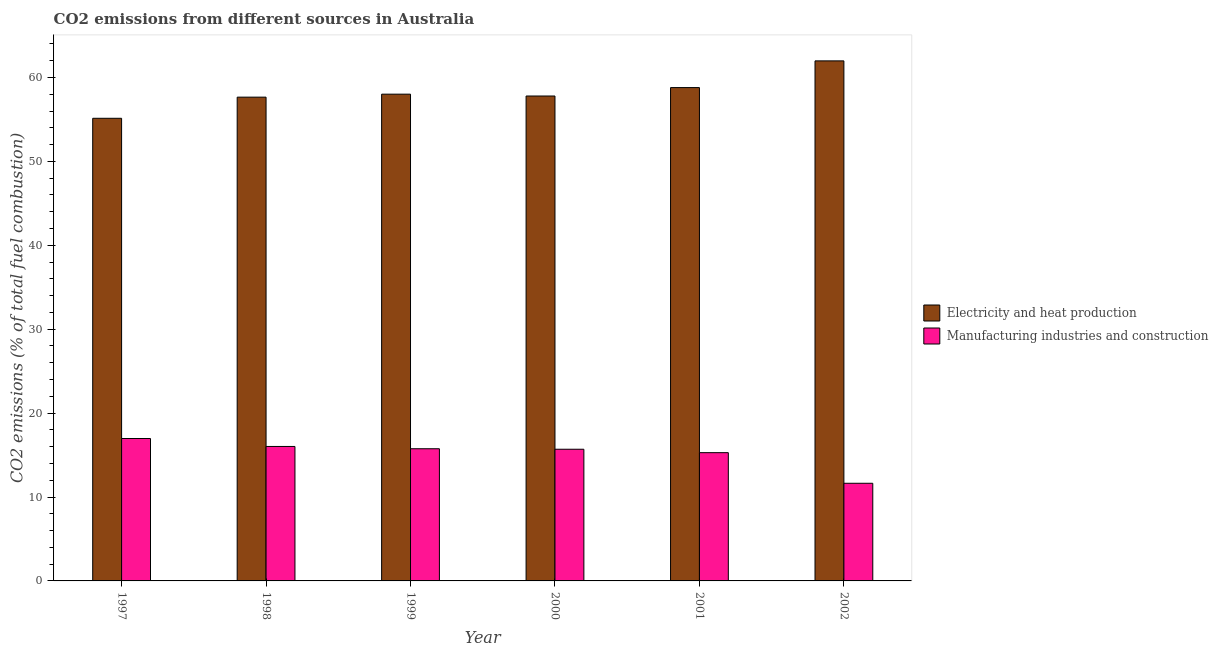How many different coloured bars are there?
Provide a succinct answer. 2. How many groups of bars are there?
Provide a short and direct response. 6. Are the number of bars on each tick of the X-axis equal?
Keep it short and to the point. Yes. How many bars are there on the 2nd tick from the left?
Your answer should be very brief. 2. How many bars are there on the 3rd tick from the right?
Ensure brevity in your answer.  2. What is the label of the 5th group of bars from the left?
Make the answer very short. 2001. In how many cases, is the number of bars for a given year not equal to the number of legend labels?
Offer a very short reply. 0. What is the co2 emissions due to electricity and heat production in 1999?
Your answer should be very brief. 58.01. Across all years, what is the maximum co2 emissions due to manufacturing industries?
Keep it short and to the point. 16.97. Across all years, what is the minimum co2 emissions due to electricity and heat production?
Make the answer very short. 55.14. In which year was the co2 emissions due to electricity and heat production maximum?
Provide a succinct answer. 2002. What is the total co2 emissions due to electricity and heat production in the graph?
Provide a short and direct response. 349.38. What is the difference between the co2 emissions due to manufacturing industries in 1998 and that in 2002?
Your response must be concise. 4.39. What is the difference between the co2 emissions due to electricity and heat production in 2000 and the co2 emissions due to manufacturing industries in 2002?
Offer a terse response. -4.19. What is the average co2 emissions due to electricity and heat production per year?
Provide a short and direct response. 58.23. What is the ratio of the co2 emissions due to manufacturing industries in 1998 to that in 2002?
Make the answer very short. 1.38. Is the difference between the co2 emissions due to electricity and heat production in 1998 and 2002 greater than the difference between the co2 emissions due to manufacturing industries in 1998 and 2002?
Your response must be concise. No. What is the difference between the highest and the second highest co2 emissions due to electricity and heat production?
Ensure brevity in your answer.  3.18. What is the difference between the highest and the lowest co2 emissions due to manufacturing industries?
Provide a succinct answer. 5.34. In how many years, is the co2 emissions due to manufacturing industries greater than the average co2 emissions due to manufacturing industries taken over all years?
Provide a short and direct response. 5. Is the sum of the co2 emissions due to electricity and heat production in 1998 and 2001 greater than the maximum co2 emissions due to manufacturing industries across all years?
Provide a short and direct response. Yes. What does the 2nd bar from the left in 2002 represents?
Your answer should be compact. Manufacturing industries and construction. What does the 2nd bar from the right in 1997 represents?
Provide a short and direct response. Electricity and heat production. Are all the bars in the graph horizontal?
Your answer should be compact. No. Where does the legend appear in the graph?
Offer a terse response. Center right. How many legend labels are there?
Ensure brevity in your answer.  2. How are the legend labels stacked?
Keep it short and to the point. Vertical. What is the title of the graph?
Your answer should be very brief. CO2 emissions from different sources in Australia. What is the label or title of the Y-axis?
Offer a very short reply. CO2 emissions (% of total fuel combustion). What is the CO2 emissions (% of total fuel combustion) in Electricity and heat production in 1997?
Offer a very short reply. 55.14. What is the CO2 emissions (% of total fuel combustion) of Manufacturing industries and construction in 1997?
Provide a short and direct response. 16.97. What is the CO2 emissions (% of total fuel combustion) of Electricity and heat production in 1998?
Provide a short and direct response. 57.66. What is the CO2 emissions (% of total fuel combustion) in Manufacturing industries and construction in 1998?
Offer a very short reply. 16.03. What is the CO2 emissions (% of total fuel combustion) in Electricity and heat production in 1999?
Provide a short and direct response. 58.01. What is the CO2 emissions (% of total fuel combustion) in Manufacturing industries and construction in 1999?
Provide a short and direct response. 15.75. What is the CO2 emissions (% of total fuel combustion) in Electricity and heat production in 2000?
Offer a very short reply. 57.79. What is the CO2 emissions (% of total fuel combustion) of Manufacturing industries and construction in 2000?
Ensure brevity in your answer.  15.69. What is the CO2 emissions (% of total fuel combustion) in Electricity and heat production in 2001?
Provide a succinct answer. 58.8. What is the CO2 emissions (% of total fuel combustion) in Manufacturing industries and construction in 2001?
Offer a terse response. 15.29. What is the CO2 emissions (% of total fuel combustion) of Electricity and heat production in 2002?
Provide a short and direct response. 61.98. What is the CO2 emissions (% of total fuel combustion) of Manufacturing industries and construction in 2002?
Offer a very short reply. 11.64. Across all years, what is the maximum CO2 emissions (% of total fuel combustion) of Electricity and heat production?
Your answer should be compact. 61.98. Across all years, what is the maximum CO2 emissions (% of total fuel combustion) in Manufacturing industries and construction?
Ensure brevity in your answer.  16.97. Across all years, what is the minimum CO2 emissions (% of total fuel combustion) in Electricity and heat production?
Keep it short and to the point. 55.14. Across all years, what is the minimum CO2 emissions (% of total fuel combustion) of Manufacturing industries and construction?
Your answer should be compact. 11.64. What is the total CO2 emissions (% of total fuel combustion) in Electricity and heat production in the graph?
Provide a succinct answer. 349.38. What is the total CO2 emissions (% of total fuel combustion) in Manufacturing industries and construction in the graph?
Keep it short and to the point. 91.37. What is the difference between the CO2 emissions (% of total fuel combustion) of Electricity and heat production in 1997 and that in 1998?
Ensure brevity in your answer.  -2.52. What is the difference between the CO2 emissions (% of total fuel combustion) of Manufacturing industries and construction in 1997 and that in 1998?
Keep it short and to the point. 0.95. What is the difference between the CO2 emissions (% of total fuel combustion) in Electricity and heat production in 1997 and that in 1999?
Make the answer very short. -2.88. What is the difference between the CO2 emissions (% of total fuel combustion) in Manufacturing industries and construction in 1997 and that in 1999?
Offer a very short reply. 1.22. What is the difference between the CO2 emissions (% of total fuel combustion) in Electricity and heat production in 1997 and that in 2000?
Your answer should be very brief. -2.66. What is the difference between the CO2 emissions (% of total fuel combustion) of Manufacturing industries and construction in 1997 and that in 2000?
Keep it short and to the point. 1.28. What is the difference between the CO2 emissions (% of total fuel combustion) in Electricity and heat production in 1997 and that in 2001?
Ensure brevity in your answer.  -3.66. What is the difference between the CO2 emissions (% of total fuel combustion) of Manufacturing industries and construction in 1997 and that in 2001?
Make the answer very short. 1.69. What is the difference between the CO2 emissions (% of total fuel combustion) in Electricity and heat production in 1997 and that in 2002?
Your answer should be compact. -6.84. What is the difference between the CO2 emissions (% of total fuel combustion) of Manufacturing industries and construction in 1997 and that in 2002?
Ensure brevity in your answer.  5.34. What is the difference between the CO2 emissions (% of total fuel combustion) of Electricity and heat production in 1998 and that in 1999?
Offer a terse response. -0.36. What is the difference between the CO2 emissions (% of total fuel combustion) in Manufacturing industries and construction in 1998 and that in 1999?
Provide a short and direct response. 0.27. What is the difference between the CO2 emissions (% of total fuel combustion) of Electricity and heat production in 1998 and that in 2000?
Offer a terse response. -0.14. What is the difference between the CO2 emissions (% of total fuel combustion) in Manufacturing industries and construction in 1998 and that in 2000?
Keep it short and to the point. 0.33. What is the difference between the CO2 emissions (% of total fuel combustion) in Electricity and heat production in 1998 and that in 2001?
Ensure brevity in your answer.  -1.14. What is the difference between the CO2 emissions (% of total fuel combustion) in Manufacturing industries and construction in 1998 and that in 2001?
Offer a terse response. 0.74. What is the difference between the CO2 emissions (% of total fuel combustion) in Electricity and heat production in 1998 and that in 2002?
Keep it short and to the point. -4.32. What is the difference between the CO2 emissions (% of total fuel combustion) in Manufacturing industries and construction in 1998 and that in 2002?
Keep it short and to the point. 4.39. What is the difference between the CO2 emissions (% of total fuel combustion) in Electricity and heat production in 1999 and that in 2000?
Provide a succinct answer. 0.22. What is the difference between the CO2 emissions (% of total fuel combustion) in Manufacturing industries and construction in 1999 and that in 2000?
Your answer should be compact. 0.06. What is the difference between the CO2 emissions (% of total fuel combustion) in Electricity and heat production in 1999 and that in 2001?
Give a very brief answer. -0.78. What is the difference between the CO2 emissions (% of total fuel combustion) of Manufacturing industries and construction in 1999 and that in 2001?
Your answer should be compact. 0.47. What is the difference between the CO2 emissions (% of total fuel combustion) in Electricity and heat production in 1999 and that in 2002?
Your answer should be very brief. -3.97. What is the difference between the CO2 emissions (% of total fuel combustion) of Manufacturing industries and construction in 1999 and that in 2002?
Provide a succinct answer. 4.12. What is the difference between the CO2 emissions (% of total fuel combustion) in Electricity and heat production in 2000 and that in 2001?
Offer a terse response. -1.01. What is the difference between the CO2 emissions (% of total fuel combustion) of Manufacturing industries and construction in 2000 and that in 2001?
Your answer should be compact. 0.41. What is the difference between the CO2 emissions (% of total fuel combustion) in Electricity and heat production in 2000 and that in 2002?
Offer a terse response. -4.19. What is the difference between the CO2 emissions (% of total fuel combustion) in Manufacturing industries and construction in 2000 and that in 2002?
Give a very brief answer. 4.06. What is the difference between the CO2 emissions (% of total fuel combustion) of Electricity and heat production in 2001 and that in 2002?
Ensure brevity in your answer.  -3.18. What is the difference between the CO2 emissions (% of total fuel combustion) of Manufacturing industries and construction in 2001 and that in 2002?
Offer a very short reply. 3.65. What is the difference between the CO2 emissions (% of total fuel combustion) of Electricity and heat production in 1997 and the CO2 emissions (% of total fuel combustion) of Manufacturing industries and construction in 1998?
Your answer should be compact. 39.11. What is the difference between the CO2 emissions (% of total fuel combustion) of Electricity and heat production in 1997 and the CO2 emissions (% of total fuel combustion) of Manufacturing industries and construction in 1999?
Keep it short and to the point. 39.38. What is the difference between the CO2 emissions (% of total fuel combustion) in Electricity and heat production in 1997 and the CO2 emissions (% of total fuel combustion) in Manufacturing industries and construction in 2000?
Ensure brevity in your answer.  39.44. What is the difference between the CO2 emissions (% of total fuel combustion) of Electricity and heat production in 1997 and the CO2 emissions (% of total fuel combustion) of Manufacturing industries and construction in 2001?
Offer a very short reply. 39.85. What is the difference between the CO2 emissions (% of total fuel combustion) in Electricity and heat production in 1997 and the CO2 emissions (% of total fuel combustion) in Manufacturing industries and construction in 2002?
Your answer should be compact. 43.5. What is the difference between the CO2 emissions (% of total fuel combustion) in Electricity and heat production in 1998 and the CO2 emissions (% of total fuel combustion) in Manufacturing industries and construction in 1999?
Make the answer very short. 41.91. What is the difference between the CO2 emissions (% of total fuel combustion) in Electricity and heat production in 1998 and the CO2 emissions (% of total fuel combustion) in Manufacturing industries and construction in 2000?
Ensure brevity in your answer.  41.96. What is the difference between the CO2 emissions (% of total fuel combustion) in Electricity and heat production in 1998 and the CO2 emissions (% of total fuel combustion) in Manufacturing industries and construction in 2001?
Ensure brevity in your answer.  42.37. What is the difference between the CO2 emissions (% of total fuel combustion) in Electricity and heat production in 1998 and the CO2 emissions (% of total fuel combustion) in Manufacturing industries and construction in 2002?
Give a very brief answer. 46.02. What is the difference between the CO2 emissions (% of total fuel combustion) in Electricity and heat production in 1999 and the CO2 emissions (% of total fuel combustion) in Manufacturing industries and construction in 2000?
Make the answer very short. 42.32. What is the difference between the CO2 emissions (% of total fuel combustion) in Electricity and heat production in 1999 and the CO2 emissions (% of total fuel combustion) in Manufacturing industries and construction in 2001?
Offer a terse response. 42.73. What is the difference between the CO2 emissions (% of total fuel combustion) in Electricity and heat production in 1999 and the CO2 emissions (% of total fuel combustion) in Manufacturing industries and construction in 2002?
Make the answer very short. 46.38. What is the difference between the CO2 emissions (% of total fuel combustion) in Electricity and heat production in 2000 and the CO2 emissions (% of total fuel combustion) in Manufacturing industries and construction in 2001?
Offer a terse response. 42.51. What is the difference between the CO2 emissions (% of total fuel combustion) in Electricity and heat production in 2000 and the CO2 emissions (% of total fuel combustion) in Manufacturing industries and construction in 2002?
Your response must be concise. 46.16. What is the difference between the CO2 emissions (% of total fuel combustion) in Electricity and heat production in 2001 and the CO2 emissions (% of total fuel combustion) in Manufacturing industries and construction in 2002?
Your response must be concise. 47.16. What is the average CO2 emissions (% of total fuel combustion) of Electricity and heat production per year?
Give a very brief answer. 58.23. What is the average CO2 emissions (% of total fuel combustion) in Manufacturing industries and construction per year?
Your answer should be compact. 15.23. In the year 1997, what is the difference between the CO2 emissions (% of total fuel combustion) of Electricity and heat production and CO2 emissions (% of total fuel combustion) of Manufacturing industries and construction?
Ensure brevity in your answer.  38.16. In the year 1998, what is the difference between the CO2 emissions (% of total fuel combustion) in Electricity and heat production and CO2 emissions (% of total fuel combustion) in Manufacturing industries and construction?
Provide a short and direct response. 41.63. In the year 1999, what is the difference between the CO2 emissions (% of total fuel combustion) of Electricity and heat production and CO2 emissions (% of total fuel combustion) of Manufacturing industries and construction?
Your response must be concise. 42.26. In the year 2000, what is the difference between the CO2 emissions (% of total fuel combustion) of Electricity and heat production and CO2 emissions (% of total fuel combustion) of Manufacturing industries and construction?
Offer a terse response. 42.1. In the year 2001, what is the difference between the CO2 emissions (% of total fuel combustion) in Electricity and heat production and CO2 emissions (% of total fuel combustion) in Manufacturing industries and construction?
Keep it short and to the point. 43.51. In the year 2002, what is the difference between the CO2 emissions (% of total fuel combustion) in Electricity and heat production and CO2 emissions (% of total fuel combustion) in Manufacturing industries and construction?
Offer a very short reply. 50.34. What is the ratio of the CO2 emissions (% of total fuel combustion) in Electricity and heat production in 1997 to that in 1998?
Ensure brevity in your answer.  0.96. What is the ratio of the CO2 emissions (% of total fuel combustion) in Manufacturing industries and construction in 1997 to that in 1998?
Your answer should be compact. 1.06. What is the ratio of the CO2 emissions (% of total fuel combustion) in Electricity and heat production in 1997 to that in 1999?
Provide a short and direct response. 0.95. What is the ratio of the CO2 emissions (% of total fuel combustion) of Manufacturing industries and construction in 1997 to that in 1999?
Your answer should be very brief. 1.08. What is the ratio of the CO2 emissions (% of total fuel combustion) of Electricity and heat production in 1997 to that in 2000?
Your answer should be very brief. 0.95. What is the ratio of the CO2 emissions (% of total fuel combustion) of Manufacturing industries and construction in 1997 to that in 2000?
Your answer should be very brief. 1.08. What is the ratio of the CO2 emissions (% of total fuel combustion) of Electricity and heat production in 1997 to that in 2001?
Your response must be concise. 0.94. What is the ratio of the CO2 emissions (% of total fuel combustion) in Manufacturing industries and construction in 1997 to that in 2001?
Make the answer very short. 1.11. What is the ratio of the CO2 emissions (% of total fuel combustion) in Electricity and heat production in 1997 to that in 2002?
Your response must be concise. 0.89. What is the ratio of the CO2 emissions (% of total fuel combustion) in Manufacturing industries and construction in 1997 to that in 2002?
Provide a succinct answer. 1.46. What is the ratio of the CO2 emissions (% of total fuel combustion) of Electricity and heat production in 1998 to that in 1999?
Make the answer very short. 0.99. What is the ratio of the CO2 emissions (% of total fuel combustion) of Manufacturing industries and construction in 1998 to that in 1999?
Offer a terse response. 1.02. What is the ratio of the CO2 emissions (% of total fuel combustion) in Manufacturing industries and construction in 1998 to that in 2000?
Keep it short and to the point. 1.02. What is the ratio of the CO2 emissions (% of total fuel combustion) of Electricity and heat production in 1998 to that in 2001?
Provide a succinct answer. 0.98. What is the ratio of the CO2 emissions (% of total fuel combustion) of Manufacturing industries and construction in 1998 to that in 2001?
Make the answer very short. 1.05. What is the ratio of the CO2 emissions (% of total fuel combustion) of Electricity and heat production in 1998 to that in 2002?
Provide a succinct answer. 0.93. What is the ratio of the CO2 emissions (% of total fuel combustion) in Manufacturing industries and construction in 1998 to that in 2002?
Give a very brief answer. 1.38. What is the ratio of the CO2 emissions (% of total fuel combustion) of Electricity and heat production in 1999 to that in 2001?
Your answer should be very brief. 0.99. What is the ratio of the CO2 emissions (% of total fuel combustion) of Manufacturing industries and construction in 1999 to that in 2001?
Ensure brevity in your answer.  1.03. What is the ratio of the CO2 emissions (% of total fuel combustion) in Electricity and heat production in 1999 to that in 2002?
Provide a short and direct response. 0.94. What is the ratio of the CO2 emissions (% of total fuel combustion) in Manufacturing industries and construction in 1999 to that in 2002?
Ensure brevity in your answer.  1.35. What is the ratio of the CO2 emissions (% of total fuel combustion) in Electricity and heat production in 2000 to that in 2001?
Offer a very short reply. 0.98. What is the ratio of the CO2 emissions (% of total fuel combustion) of Manufacturing industries and construction in 2000 to that in 2001?
Keep it short and to the point. 1.03. What is the ratio of the CO2 emissions (% of total fuel combustion) in Electricity and heat production in 2000 to that in 2002?
Make the answer very short. 0.93. What is the ratio of the CO2 emissions (% of total fuel combustion) of Manufacturing industries and construction in 2000 to that in 2002?
Provide a succinct answer. 1.35. What is the ratio of the CO2 emissions (% of total fuel combustion) in Electricity and heat production in 2001 to that in 2002?
Offer a very short reply. 0.95. What is the ratio of the CO2 emissions (% of total fuel combustion) in Manufacturing industries and construction in 2001 to that in 2002?
Your answer should be very brief. 1.31. What is the difference between the highest and the second highest CO2 emissions (% of total fuel combustion) of Electricity and heat production?
Provide a short and direct response. 3.18. What is the difference between the highest and the second highest CO2 emissions (% of total fuel combustion) of Manufacturing industries and construction?
Your answer should be compact. 0.95. What is the difference between the highest and the lowest CO2 emissions (% of total fuel combustion) of Electricity and heat production?
Your answer should be compact. 6.84. What is the difference between the highest and the lowest CO2 emissions (% of total fuel combustion) in Manufacturing industries and construction?
Offer a very short reply. 5.34. 